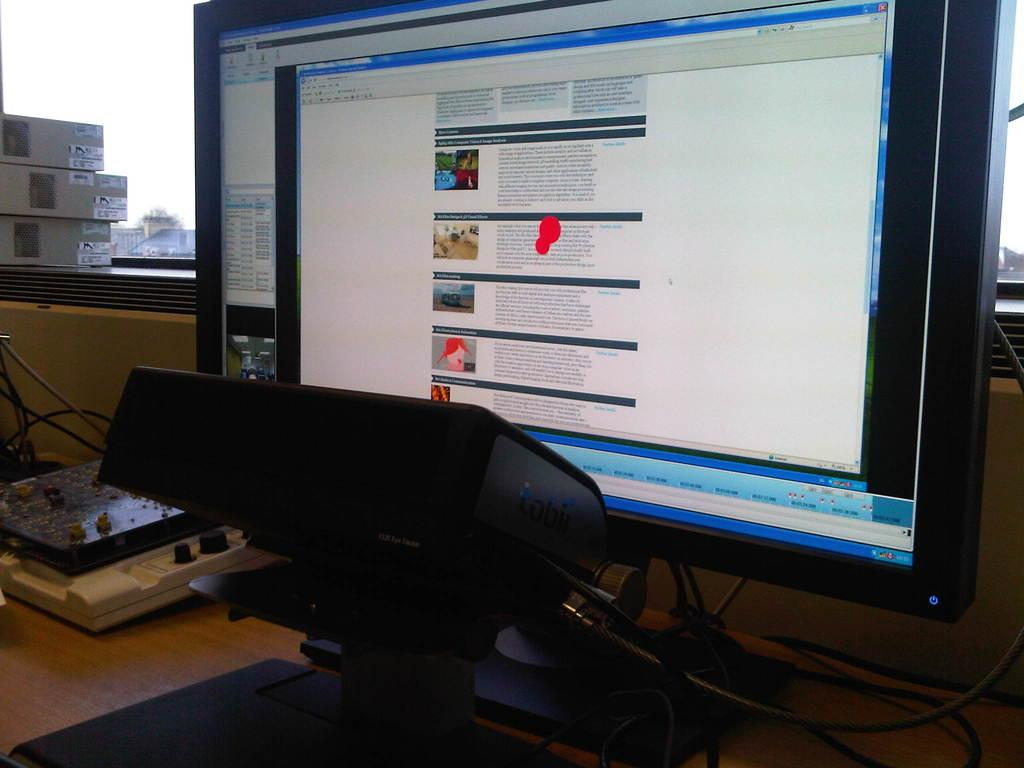What electronic device is present in the image? There is a monitor in the image. What type of devices are connected to the monitor? There are wired devices in the image. Where are the devices located? The devices are on a table in the image. What else can be seen on the table? There are boxes in the image. What can be seen through the glass in the image? A building and the sky are visible through the glass. Where is the rabbit playing in the image? There is no rabbit present in the image. What type of baby is visible in the image? There is no baby present in the image. 